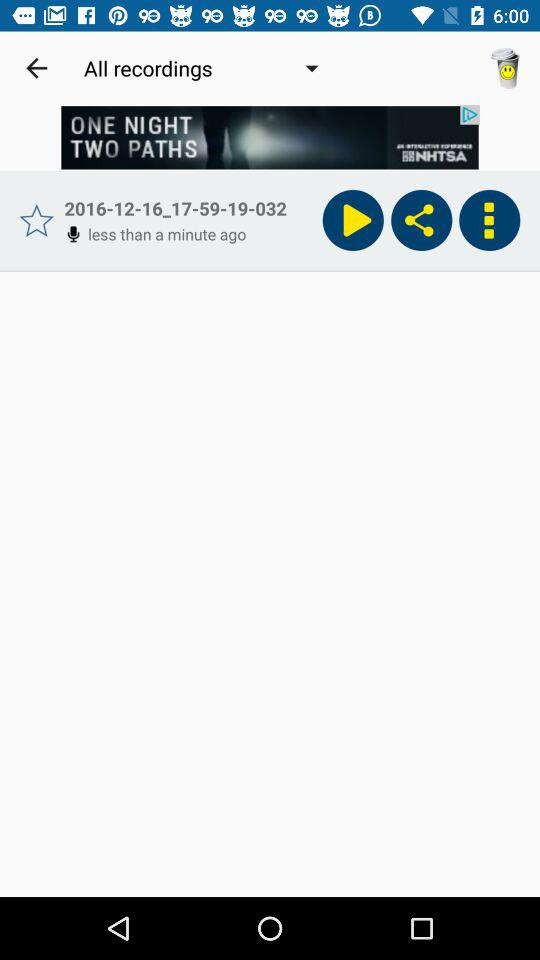What is the date?
When the provided information is insufficient, respond with <no answer>. <no answer> 